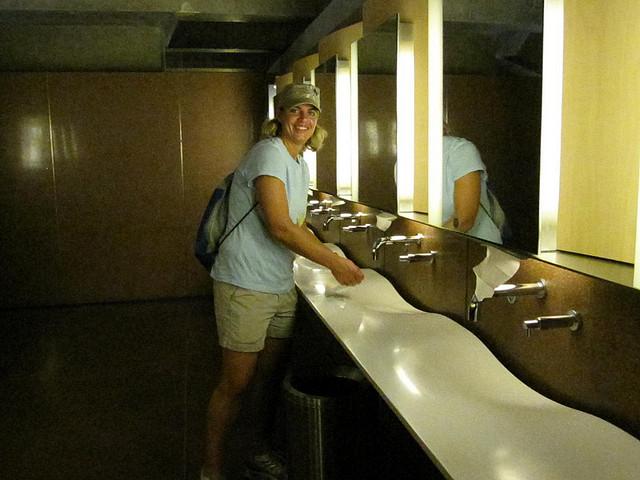Is this restroom for men?
Be succinct. No. Is this sink structure a work of art?
Write a very short answer. Yes. How many sinks are being used?
Answer briefly. 1. 